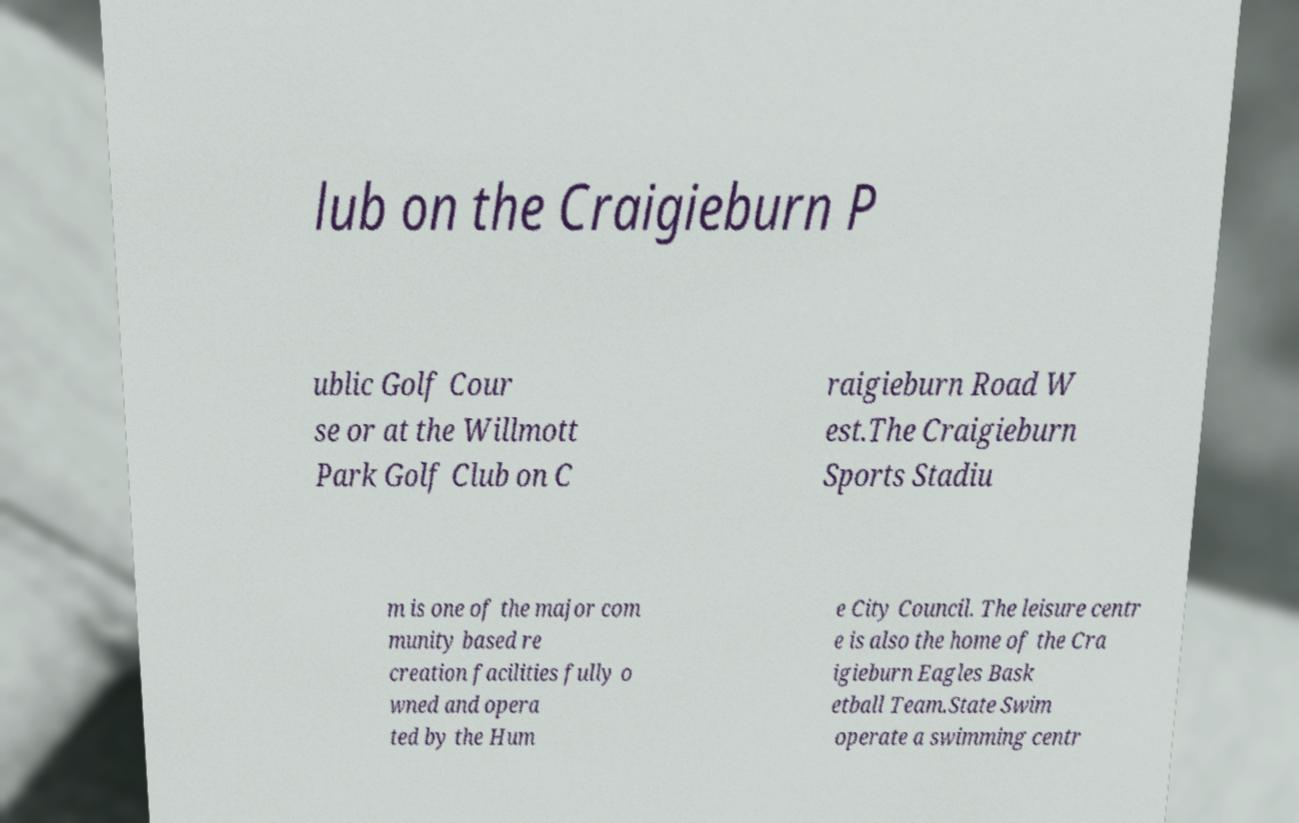Can you read and provide the text displayed in the image?This photo seems to have some interesting text. Can you extract and type it out for me? lub on the Craigieburn P ublic Golf Cour se or at the Willmott Park Golf Club on C raigieburn Road W est.The Craigieburn Sports Stadiu m is one of the major com munity based re creation facilities fully o wned and opera ted by the Hum e City Council. The leisure centr e is also the home of the Cra igieburn Eagles Bask etball Team.State Swim operate a swimming centr 